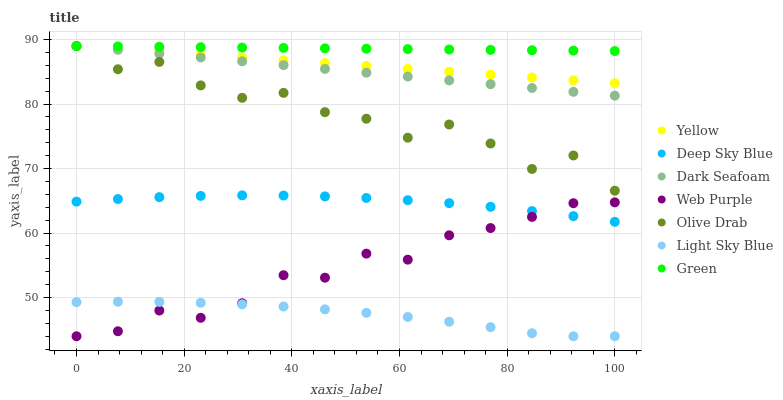Does Light Sky Blue have the minimum area under the curve?
Answer yes or no. Yes. Does Green have the maximum area under the curve?
Answer yes or no. Yes. Does Yellow have the minimum area under the curve?
Answer yes or no. No. Does Yellow have the maximum area under the curve?
Answer yes or no. No. Is Green the smoothest?
Answer yes or no. Yes. Is Olive Drab the roughest?
Answer yes or no. Yes. Is Yellow the smoothest?
Answer yes or no. No. Is Yellow the roughest?
Answer yes or no. No. Does Web Purple have the lowest value?
Answer yes or no. Yes. Does Yellow have the lowest value?
Answer yes or no. No. Does Olive Drab have the highest value?
Answer yes or no. Yes. Does Web Purple have the highest value?
Answer yes or no. No. Is Light Sky Blue less than Olive Drab?
Answer yes or no. Yes. Is Green greater than Deep Sky Blue?
Answer yes or no. Yes. Does Olive Drab intersect Dark Seafoam?
Answer yes or no. Yes. Is Olive Drab less than Dark Seafoam?
Answer yes or no. No. Is Olive Drab greater than Dark Seafoam?
Answer yes or no. No. Does Light Sky Blue intersect Olive Drab?
Answer yes or no. No. 